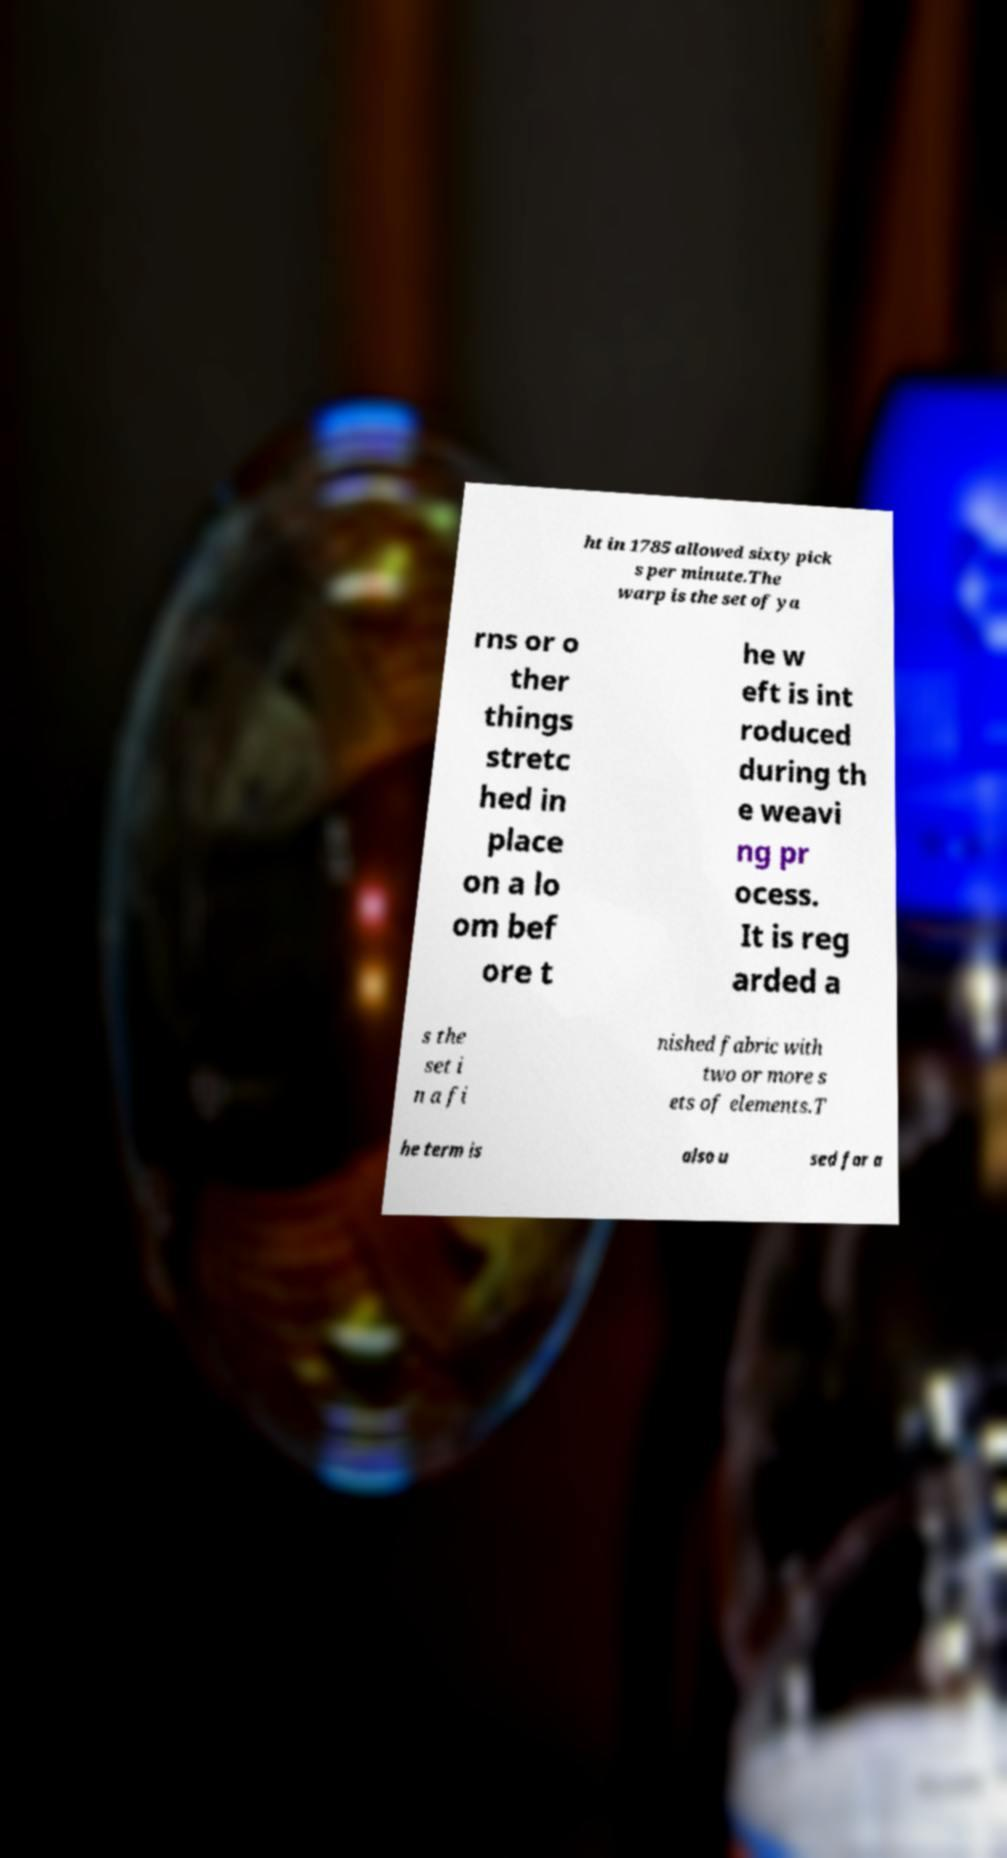What messages or text are displayed in this image? I need them in a readable, typed format. ht in 1785 allowed sixty pick s per minute.The warp is the set of ya rns or o ther things stretc hed in place on a lo om bef ore t he w eft is int roduced during th e weavi ng pr ocess. It is reg arded a s the set i n a fi nished fabric with two or more s ets of elements.T he term is also u sed for a 